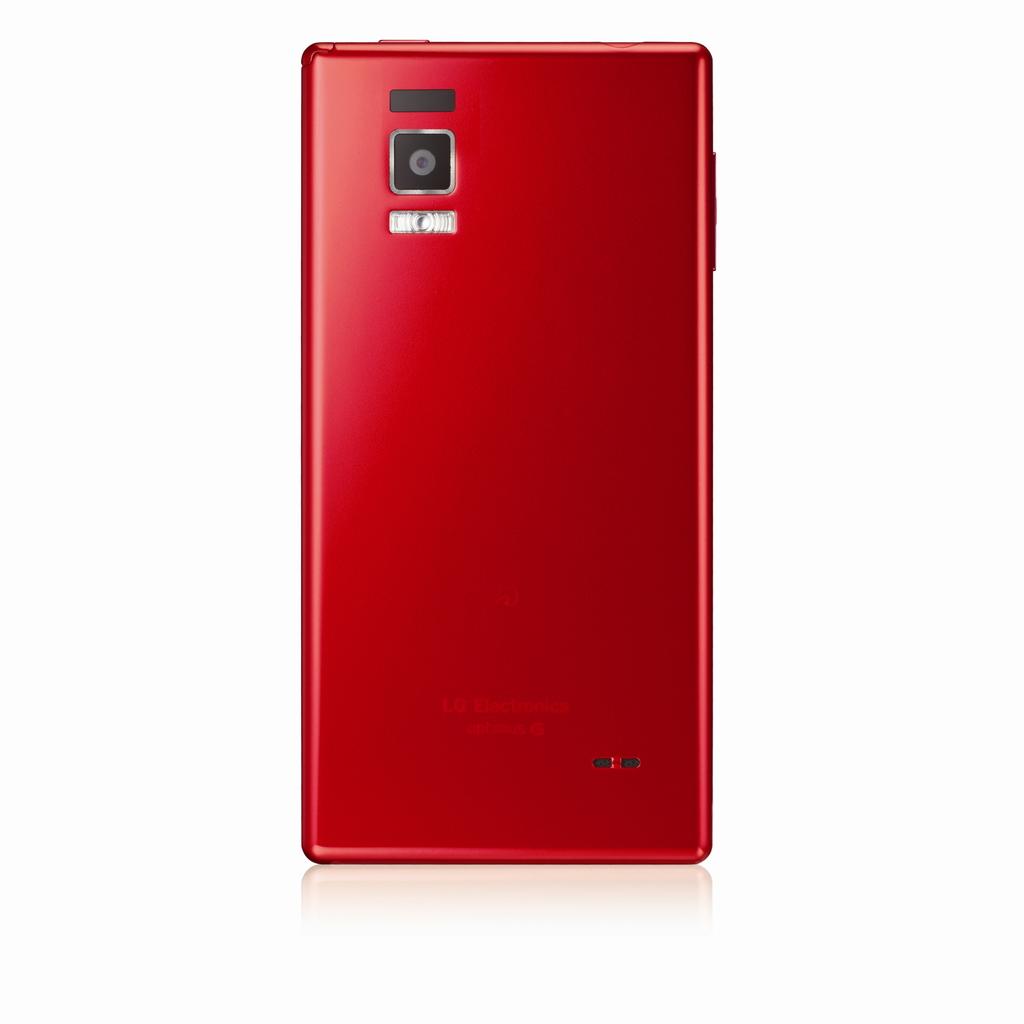What brand is this phone?
Your answer should be compact. Lg. 